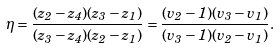<formula> <loc_0><loc_0><loc_500><loc_500>\eta = \frac { ( z _ { 2 } - z _ { 4 } ) ( z _ { 3 } - z _ { 1 } ) } { ( z _ { 3 } - z _ { 4 } ) ( z _ { 2 } - z _ { 1 } ) } = \frac { ( v _ { 2 } - 1 ) ( v _ { 3 } - v _ { 1 } ) } { ( v _ { 3 } - 1 ) ( v _ { 2 } - v _ { 1 } ) } .</formula> 